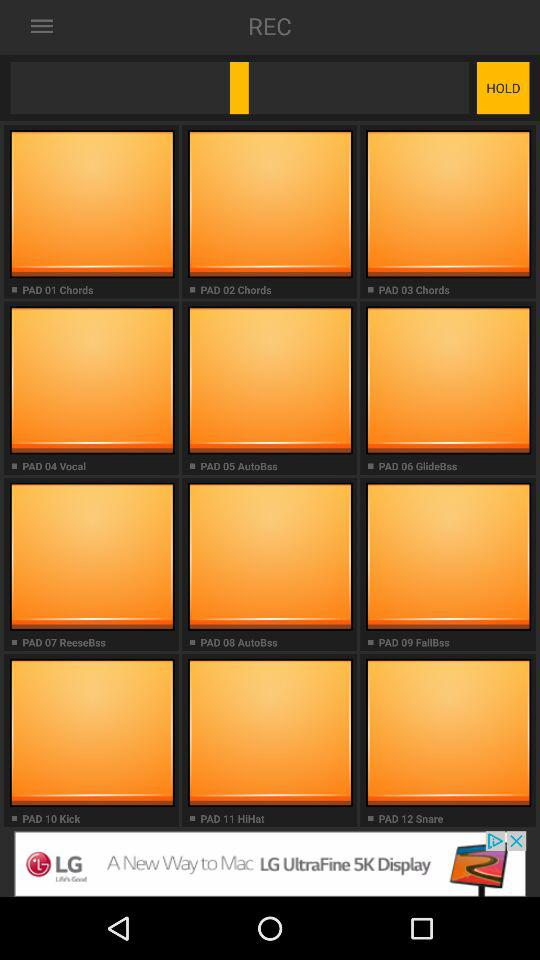What is the name of the application? The name of the application is "Dubstep Drum Pads 24". 